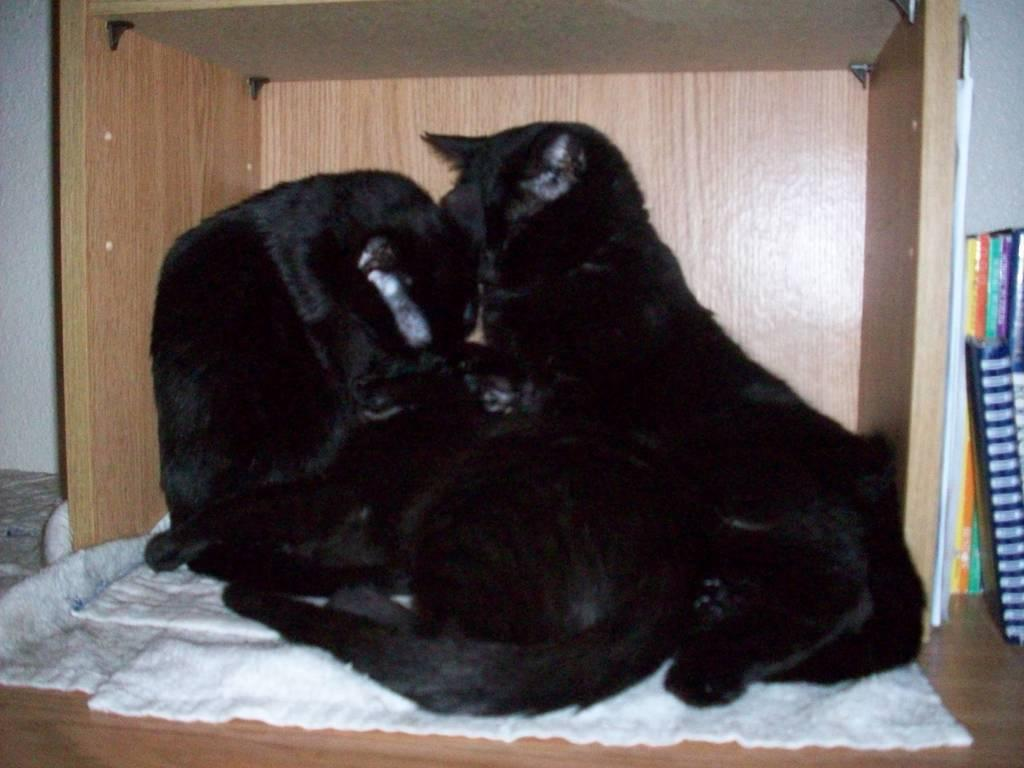What type of animals are on the wooden table in the image? There are black cats on the wooden table in the image. What can be seen on the right side of the image? There is a white towel and books on the right side of the image. What is visible at the back of the image? There is a wall at the back of the image. How many dogs are present in the image? There are no dogs present in the image; it features black cats on a wooden table. What type of cough is the cat exhibiting in the image? There is no indication of a cough in the image, as it features black cats on a wooden table, a white towel, books, and a wall. 